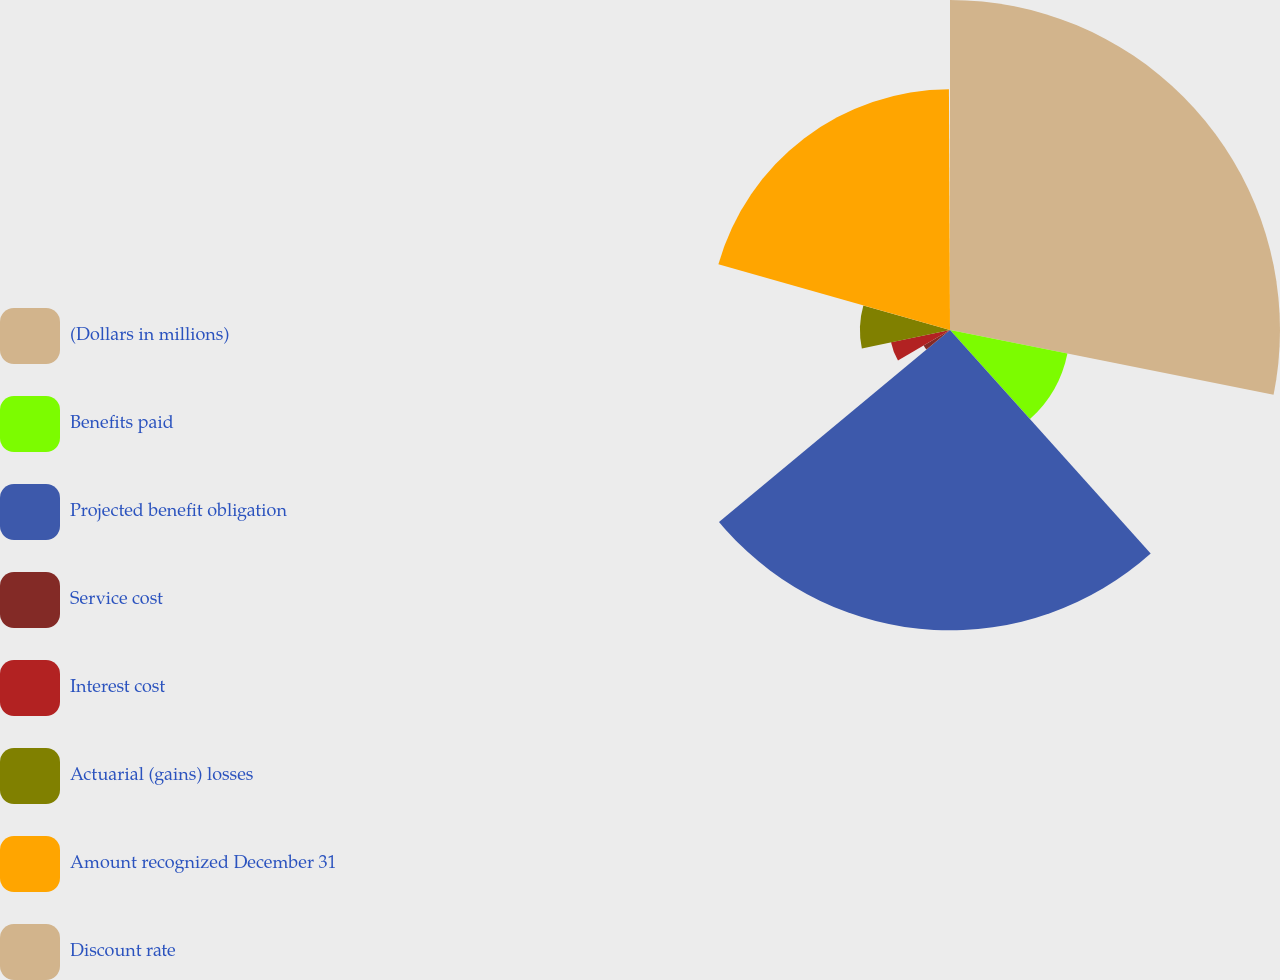Convert chart. <chart><loc_0><loc_0><loc_500><loc_500><pie_chart><fcel>(Dollars in millions)<fcel>Benefits paid<fcel>Projected benefit obligation<fcel>Service cost<fcel>Interest cost<fcel>Actuarial (gains) losses<fcel>Amount recognized December 31<fcel>Discount rate<nl><fcel>28.14%<fcel>10.21%<fcel>25.61%<fcel>2.61%<fcel>5.14%<fcel>7.68%<fcel>20.53%<fcel>0.07%<nl></chart> 